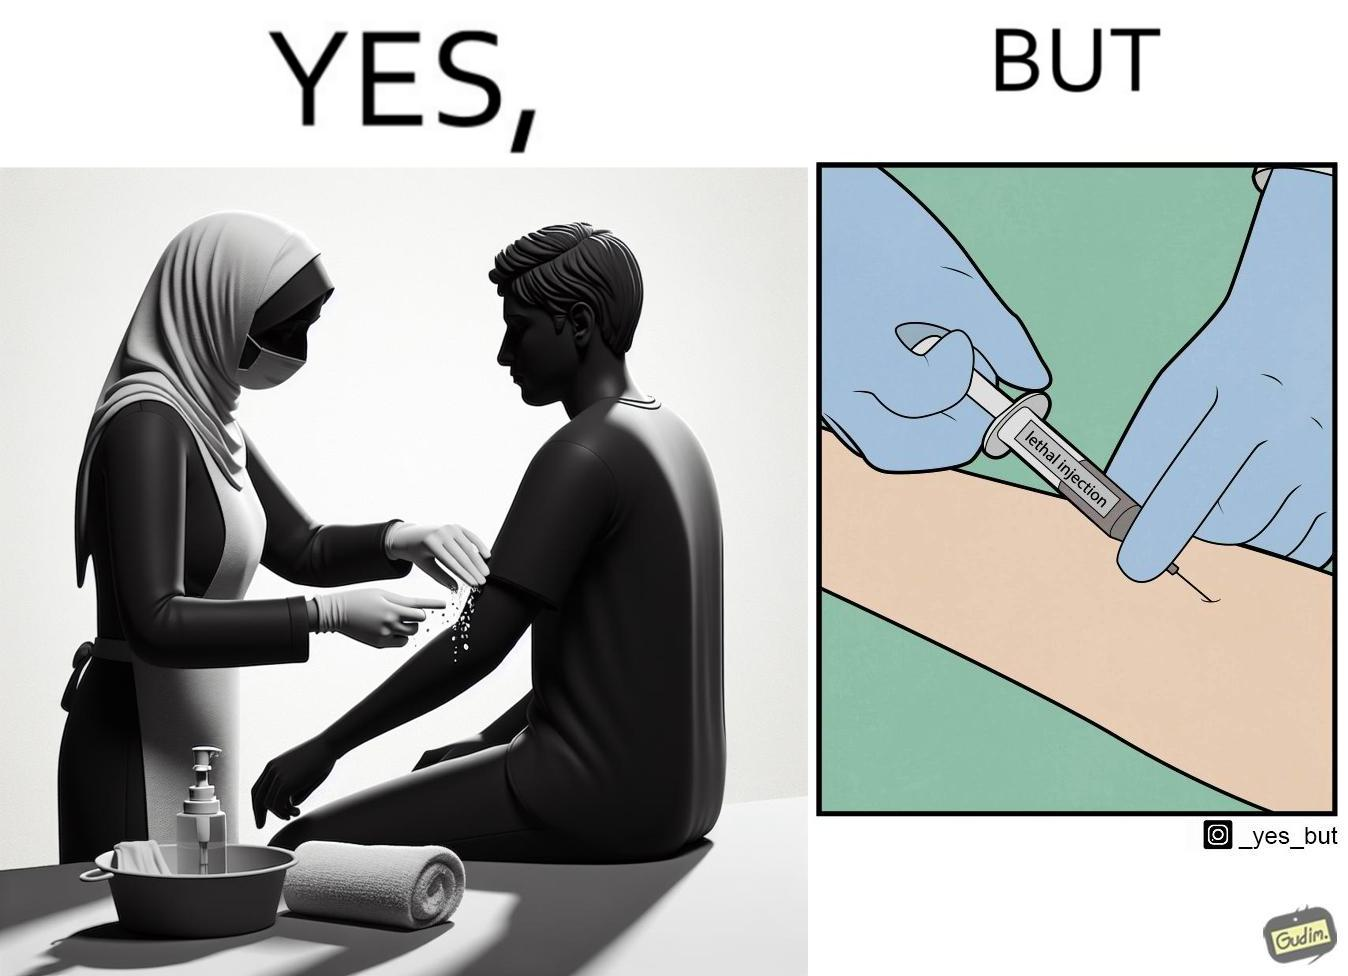Describe the contrast between the left and right parts of this image. In the left part of the image: a doctor/nurse rubbing alcohol on a patient's arm. In the right part of the image: a doctor/nurse injecting a 'lethal injection' into the patient's arm. 